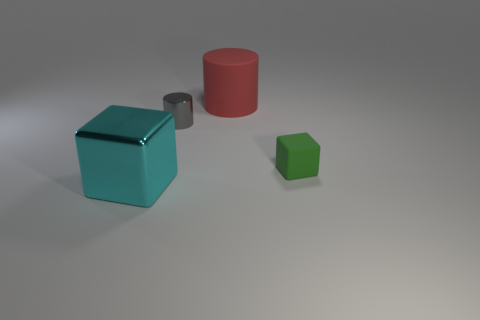Are there the same number of metallic cylinders that are in front of the rubber block and small purple cylinders?
Keep it short and to the point. Yes. The big object right of the large thing left of the tiny metal cylinder is what color?
Your answer should be compact. Red. There is a green rubber thing that is to the right of the rubber object on the left side of the green thing; what is its size?
Give a very brief answer. Small. How many other things are there of the same size as the green thing?
Keep it short and to the point. 1. There is a tiny object that is left of the large object right of the block that is to the left of the tiny gray cylinder; what color is it?
Your answer should be compact. Gray. What number of other things are the same shape as the big cyan object?
Your response must be concise. 1. The big thing that is behind the shiny cylinder has what shape?
Give a very brief answer. Cylinder. Is there a small rubber object behind the big thing behind the tiny gray cylinder?
Keep it short and to the point. No. What color is the thing that is both to the right of the small gray metallic cylinder and on the left side of the tiny matte object?
Provide a short and direct response. Red. Are there any shiny objects left of the cylinder that is to the left of the rubber thing that is behind the tiny gray thing?
Make the answer very short. Yes. 